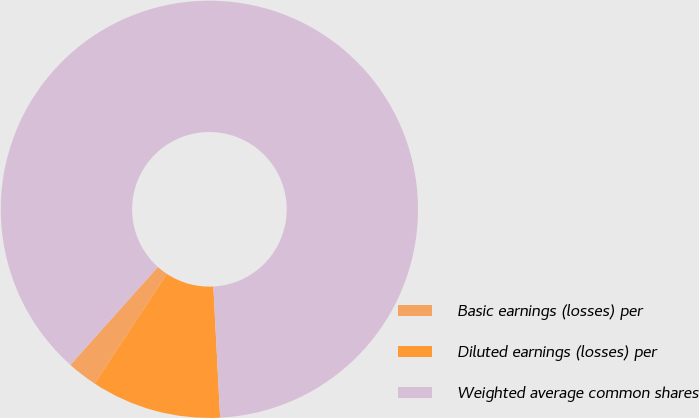Convert chart to OTSL. <chart><loc_0><loc_0><loc_500><loc_500><pie_chart><fcel>Basic earnings (losses) per<fcel>Diluted earnings (losses) per<fcel>Weighted average common shares<nl><fcel>2.34%<fcel>10.09%<fcel>87.57%<nl></chart> 